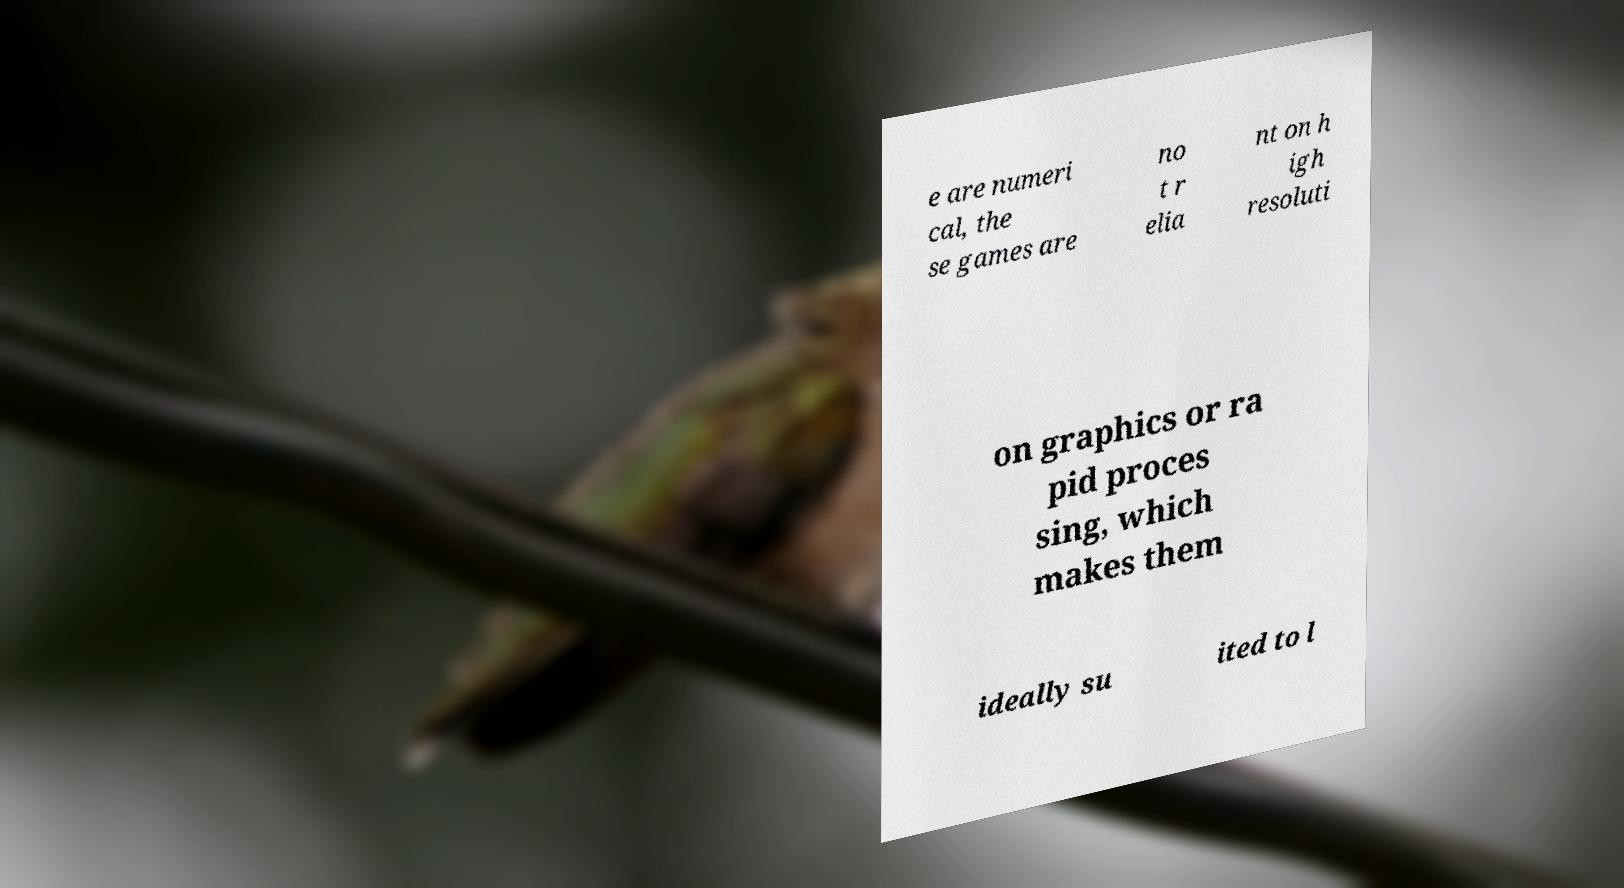There's text embedded in this image that I need extracted. Can you transcribe it verbatim? e are numeri cal, the se games are no t r elia nt on h igh resoluti on graphics or ra pid proces sing, which makes them ideally su ited to l 